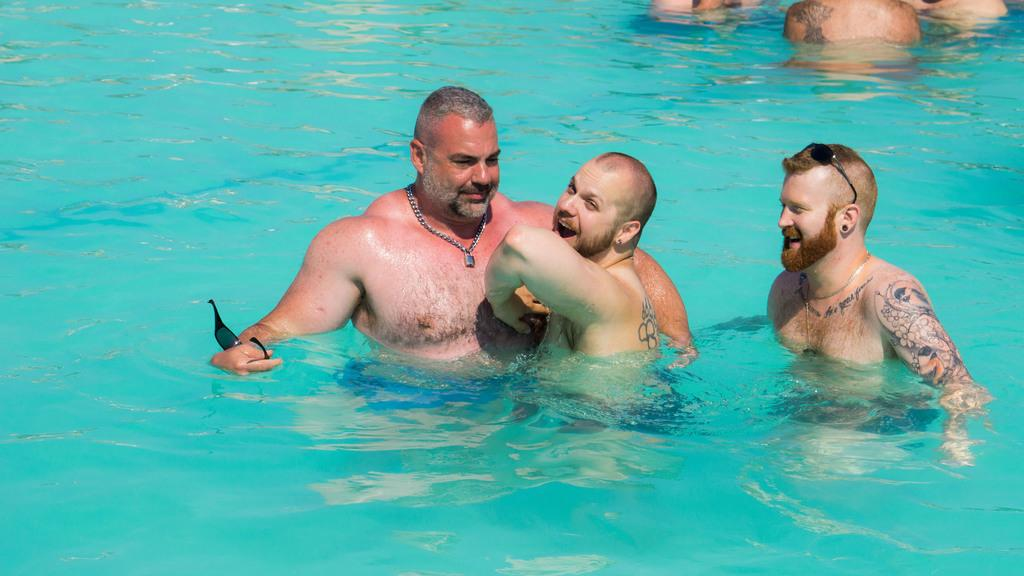How many men are in the swimming pool in the image? There are six men in the swimming pool in the image, three on the bottom and three at the top. What are the men in the swimming pool doing? The men are swimming in the swimming pool. What type of dock can be seen near the swimming pool in the image? There is no dock present in the image; it only shows a swimming pool with men swimming in it. 